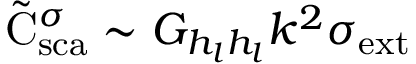Convert formula to latex. <formula><loc_0><loc_0><loc_500><loc_500>\tilde { C } _ { s c a } ^ { \sigma } \sim G _ { h _ { l } h _ { l } } k ^ { 2 } { \sigma } _ { e x t }</formula> 